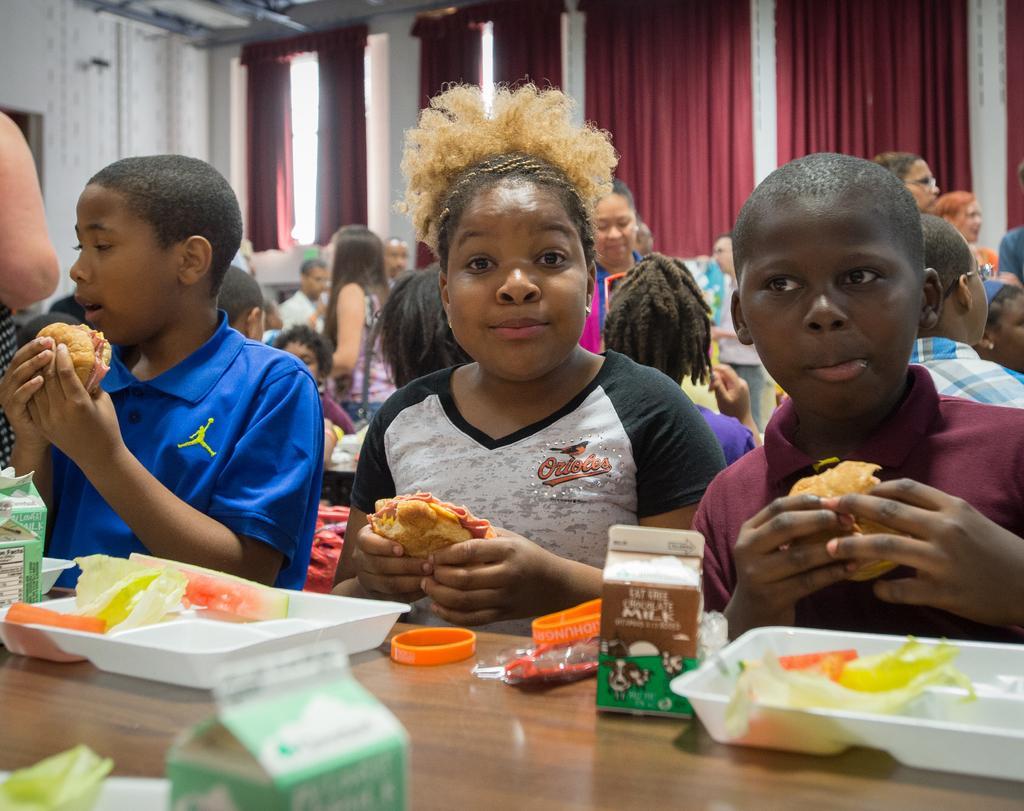In one or two sentences, can you explain what this image depicts? This picture might be taken inside the room. In this image, we can see three kids are holding food item and sitting on the chair in front of the table, on that table, we can see a plates, boxes, band. On the left side, we can also see hand of a person. In the background, we can see a group of people standing, we can also see a group of kids are sitting on the chair in front of the table. In the background, we can also see curtains and a wall. 